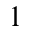<formula> <loc_0><loc_0><loc_500><loc_500>1</formula> 